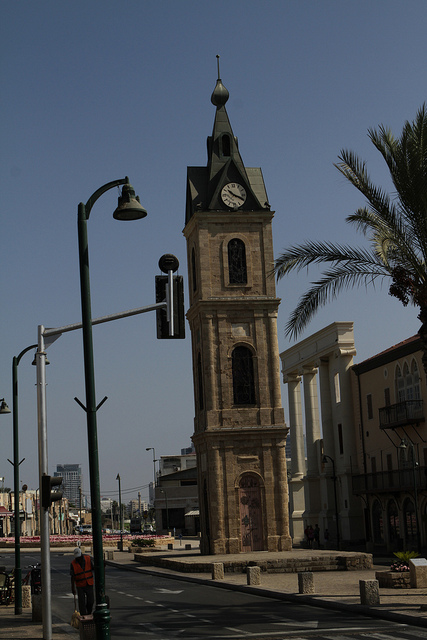<image>What item is on top of the ledge? I am not sure what item is on top of the ledge. It can be a bird, a clock, or a goat. What is the speed limit on this road? It is unknown what the speed limit on this road is. What color is the ground under the fire hydrant? I don't know what color is the ground under the fire hydrant. It can be black, brown, tan or gray. What is the speed limit on this road? I don't know the speed limit on this road. It is unknown. What item is on top of the ledge? I am not sure what item is on top of the ledge. It can be seen a bird, a clock, or a goat. What color is the ground under the fire hydrant? It is ambiguous what color is the ground under the fire hydrant. It can be seen black, brown or gray. 